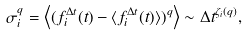<formula> <loc_0><loc_0><loc_500><loc_500>\sigma _ { i } ^ { q } = \left \langle ( f _ { i } ^ { \Delta t } ( t ) - \langle f _ { i } ^ { \Delta t } ( t ) \rangle ) ^ { q } \right \rangle \sim \Delta t ^ { \zeta _ { i } ( q ) } ,</formula> 